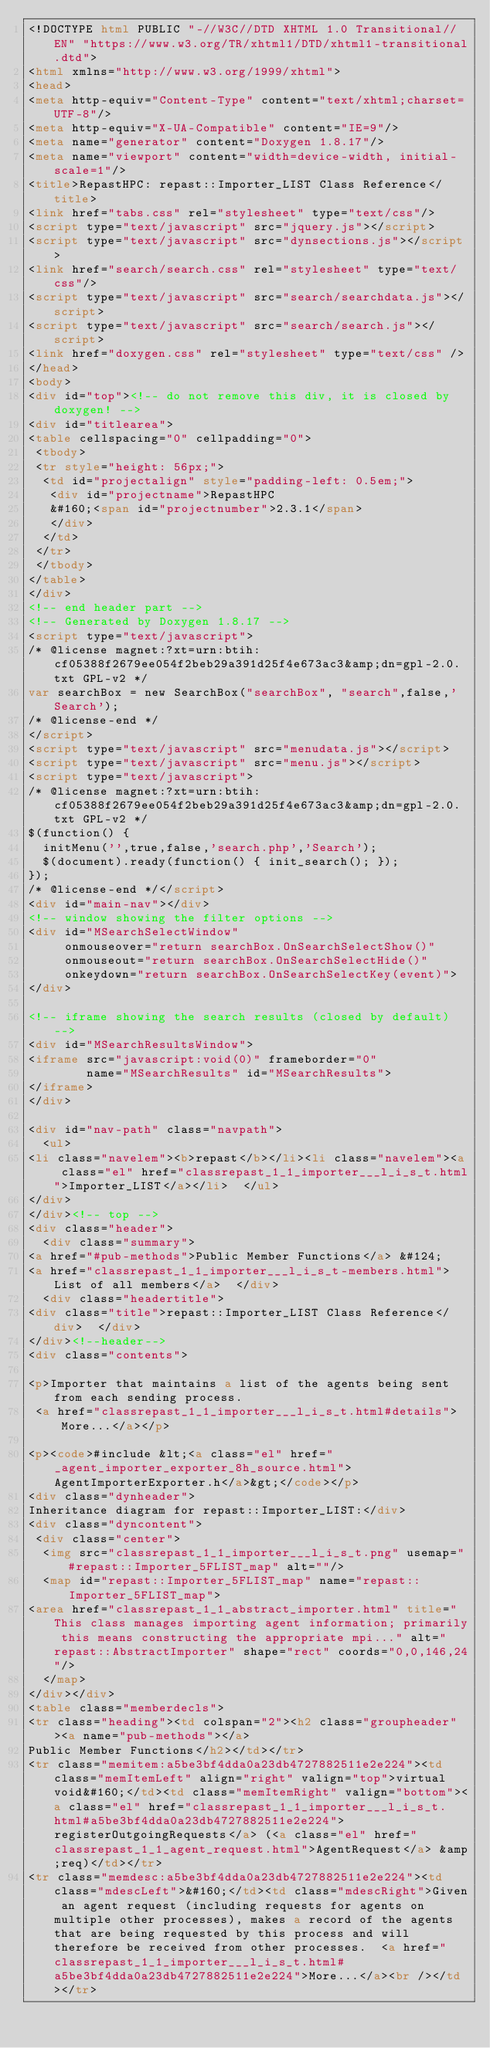<code> <loc_0><loc_0><loc_500><loc_500><_HTML_><!DOCTYPE html PUBLIC "-//W3C//DTD XHTML 1.0 Transitional//EN" "https://www.w3.org/TR/xhtml1/DTD/xhtml1-transitional.dtd">
<html xmlns="http://www.w3.org/1999/xhtml">
<head>
<meta http-equiv="Content-Type" content="text/xhtml;charset=UTF-8"/>
<meta http-equiv="X-UA-Compatible" content="IE=9"/>
<meta name="generator" content="Doxygen 1.8.17"/>
<meta name="viewport" content="width=device-width, initial-scale=1"/>
<title>RepastHPC: repast::Importer_LIST Class Reference</title>
<link href="tabs.css" rel="stylesheet" type="text/css"/>
<script type="text/javascript" src="jquery.js"></script>
<script type="text/javascript" src="dynsections.js"></script>
<link href="search/search.css" rel="stylesheet" type="text/css"/>
<script type="text/javascript" src="search/searchdata.js"></script>
<script type="text/javascript" src="search/search.js"></script>
<link href="doxygen.css" rel="stylesheet" type="text/css" />
</head>
<body>
<div id="top"><!-- do not remove this div, it is closed by doxygen! -->
<div id="titlearea">
<table cellspacing="0" cellpadding="0">
 <tbody>
 <tr style="height: 56px;">
  <td id="projectalign" style="padding-left: 0.5em;">
   <div id="projectname">RepastHPC
   &#160;<span id="projectnumber">2.3.1</span>
   </div>
  </td>
 </tr>
 </tbody>
</table>
</div>
<!-- end header part -->
<!-- Generated by Doxygen 1.8.17 -->
<script type="text/javascript">
/* @license magnet:?xt=urn:btih:cf05388f2679ee054f2beb29a391d25f4e673ac3&amp;dn=gpl-2.0.txt GPL-v2 */
var searchBox = new SearchBox("searchBox", "search",false,'Search');
/* @license-end */
</script>
<script type="text/javascript" src="menudata.js"></script>
<script type="text/javascript" src="menu.js"></script>
<script type="text/javascript">
/* @license magnet:?xt=urn:btih:cf05388f2679ee054f2beb29a391d25f4e673ac3&amp;dn=gpl-2.0.txt GPL-v2 */
$(function() {
  initMenu('',true,false,'search.php','Search');
  $(document).ready(function() { init_search(); });
});
/* @license-end */</script>
<div id="main-nav"></div>
<!-- window showing the filter options -->
<div id="MSearchSelectWindow"
     onmouseover="return searchBox.OnSearchSelectShow()"
     onmouseout="return searchBox.OnSearchSelectHide()"
     onkeydown="return searchBox.OnSearchSelectKey(event)">
</div>

<!-- iframe showing the search results (closed by default) -->
<div id="MSearchResultsWindow">
<iframe src="javascript:void(0)" frameborder="0" 
        name="MSearchResults" id="MSearchResults">
</iframe>
</div>

<div id="nav-path" class="navpath">
  <ul>
<li class="navelem"><b>repast</b></li><li class="navelem"><a class="el" href="classrepast_1_1_importer___l_i_s_t.html">Importer_LIST</a></li>  </ul>
</div>
</div><!-- top -->
<div class="header">
  <div class="summary">
<a href="#pub-methods">Public Member Functions</a> &#124;
<a href="classrepast_1_1_importer___l_i_s_t-members.html">List of all members</a>  </div>
  <div class="headertitle">
<div class="title">repast::Importer_LIST Class Reference</div>  </div>
</div><!--header-->
<div class="contents">

<p>Importer that maintains a list of the agents being sent from each sending process.  
 <a href="classrepast_1_1_importer___l_i_s_t.html#details">More...</a></p>

<p><code>#include &lt;<a class="el" href="_agent_importer_exporter_8h_source.html">AgentImporterExporter.h</a>&gt;</code></p>
<div class="dynheader">
Inheritance diagram for repast::Importer_LIST:</div>
<div class="dyncontent">
 <div class="center">
  <img src="classrepast_1_1_importer___l_i_s_t.png" usemap="#repast::Importer_5FLIST_map" alt=""/>
  <map id="repast::Importer_5FLIST_map" name="repast::Importer_5FLIST_map">
<area href="classrepast_1_1_abstract_importer.html" title="This class manages importing agent information; primarily this means constructing the appropriate mpi..." alt="repast::AbstractImporter" shape="rect" coords="0,0,146,24"/>
  </map>
</div></div>
<table class="memberdecls">
<tr class="heading"><td colspan="2"><h2 class="groupheader"><a name="pub-methods"></a>
Public Member Functions</h2></td></tr>
<tr class="memitem:a5be3bf4dda0a23db4727882511e2e224"><td class="memItemLeft" align="right" valign="top">virtual void&#160;</td><td class="memItemRight" valign="bottom"><a class="el" href="classrepast_1_1_importer___l_i_s_t.html#a5be3bf4dda0a23db4727882511e2e224">registerOutgoingRequests</a> (<a class="el" href="classrepast_1_1_agent_request.html">AgentRequest</a> &amp;req)</td></tr>
<tr class="memdesc:a5be3bf4dda0a23db4727882511e2e224"><td class="mdescLeft">&#160;</td><td class="mdescRight">Given an agent request (including requests for agents on multiple other processes), makes a record of the agents that are being requested by this process and will therefore be received from other processes.  <a href="classrepast_1_1_importer___l_i_s_t.html#a5be3bf4dda0a23db4727882511e2e224">More...</a><br /></td></tr></code> 